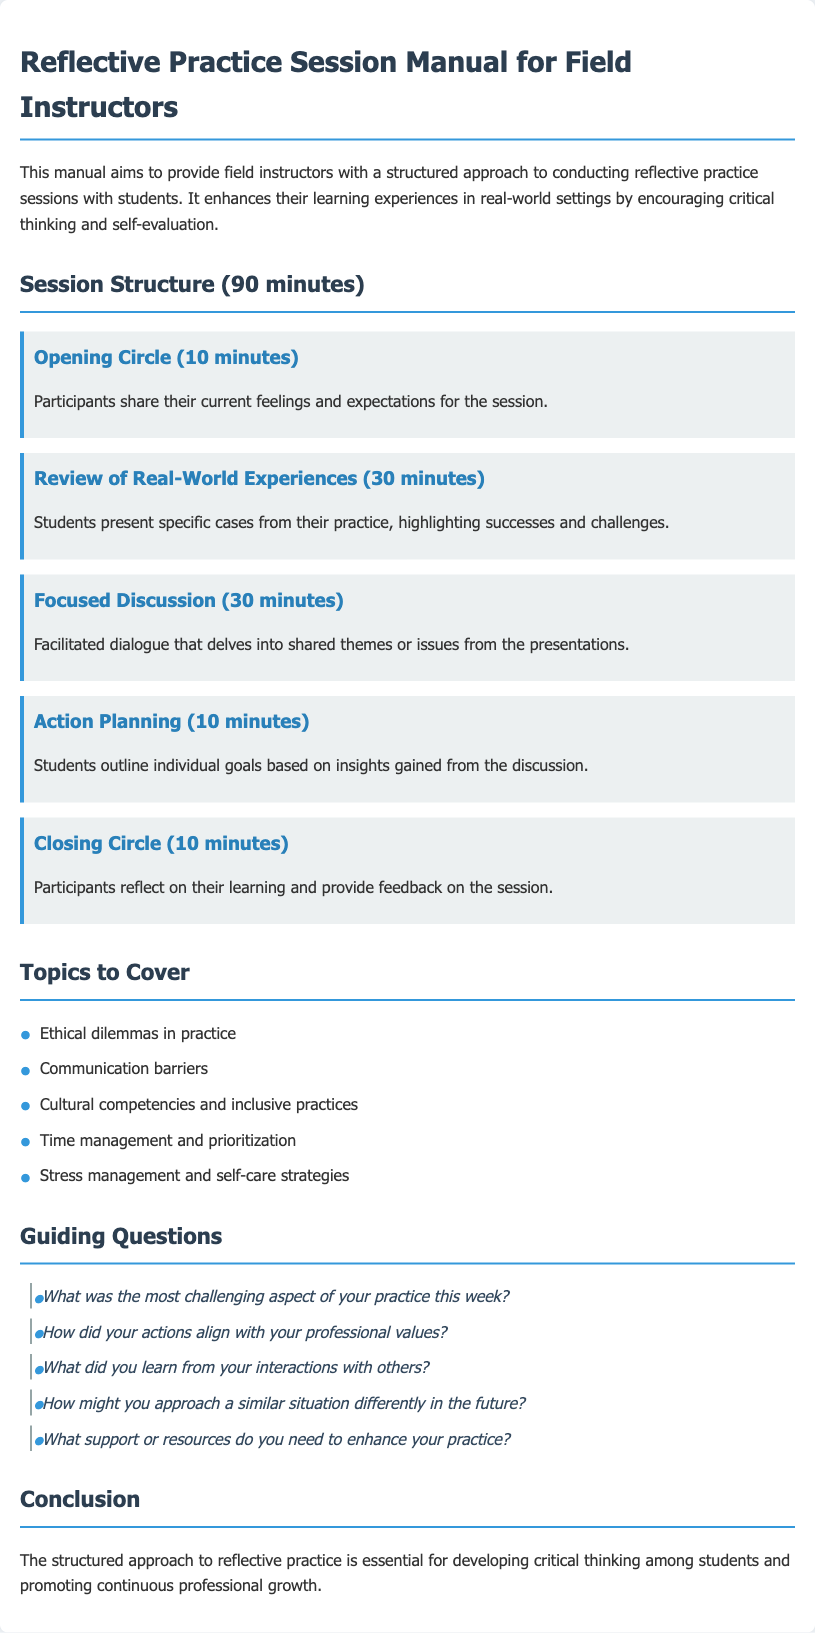What is the total duration of the reflective practice session? The total duration is specified in the session structure segment of the document as 90 minutes.
Answer: 90 minutes What is the first component of the session structure? The first component described in the session structure is the Opening Circle, which lasts for 10 minutes.
Answer: Opening Circle What is one topic to cover in the sessions? Topics to cover are listed in a specific section, one example is ethical dilemmas in practice.
Answer: Ethical dilemmas in practice How many minutes are allocated to Action Planning? The Action Planning section of the session structure mentions a duration of 10 minutes for this activity.
Answer: 10 minutes What is the focus of the Focused Discussion component? The Focused Discussion is designed for facilitated dialogue that delves into shared themes or issues from the presentations made by students.
Answer: Shared themes or issues What type of questions are included in the Guiding Questions section? The Guiding Questions are meant to prompt reflection on students' practices and may include questions about challenges, actions, and future plans.
Answer: Reflective questions How many total components are outlined in the session structure? The session structure presents a total of five distinct components that guide the reflective practice session.
Answer: Five What is the last component of the session structure? The last segment listed in the structure is the Closing Circle, intended for participants to reflect on their learning.
Answer: Closing Circle What is the purpose of this manual? The purpose is to provide field instructors with a structured approach to conducting reflective practice sessions with students.
Answer: Structured approach to reflective practice sessions 